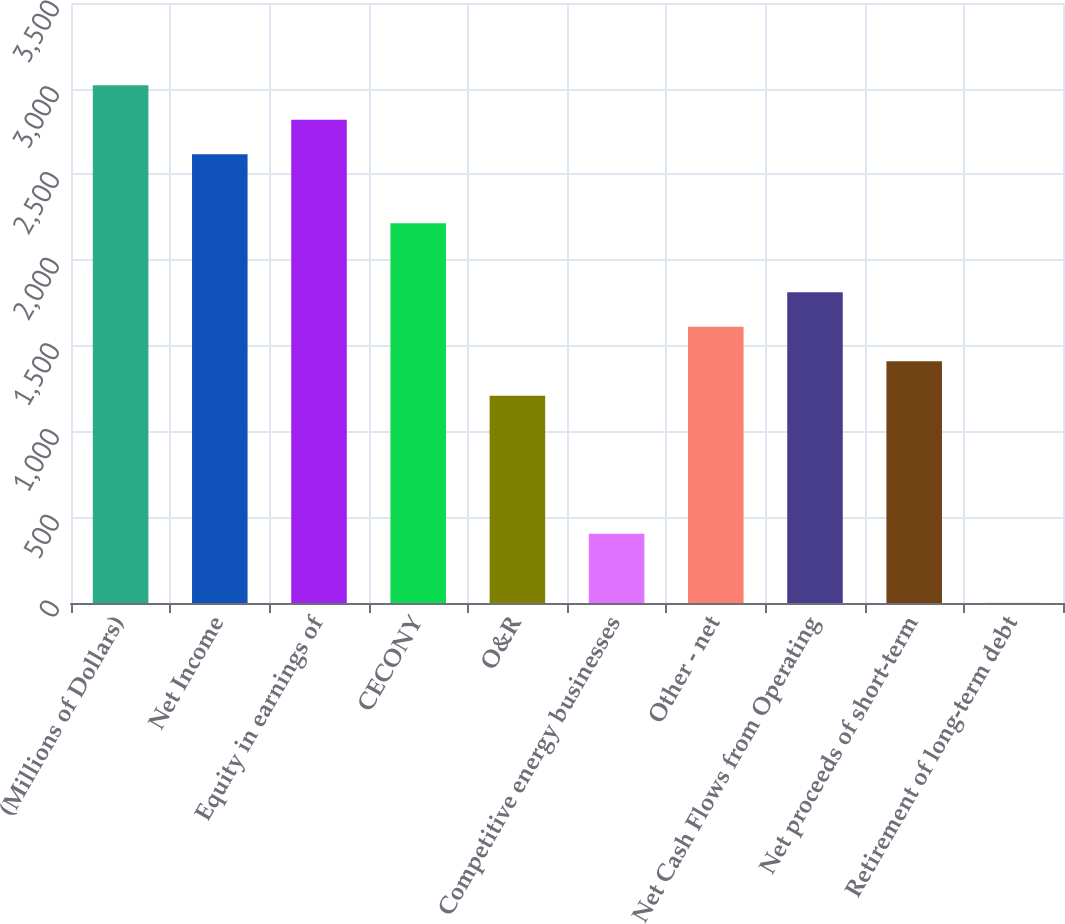Convert chart to OTSL. <chart><loc_0><loc_0><loc_500><loc_500><bar_chart><fcel>(Millions of Dollars)<fcel>Net Income<fcel>Equity in earnings of<fcel>CECONY<fcel>O&R<fcel>Competitive energy businesses<fcel>Other - net<fcel>Net Cash Flows from Operating<fcel>Net proceeds of short-term<fcel>Retirement of long-term debt<nl><fcel>3020<fcel>2617.6<fcel>2818.8<fcel>2215.2<fcel>1209.2<fcel>404.4<fcel>1611.6<fcel>1812.8<fcel>1410.4<fcel>2<nl></chart> 